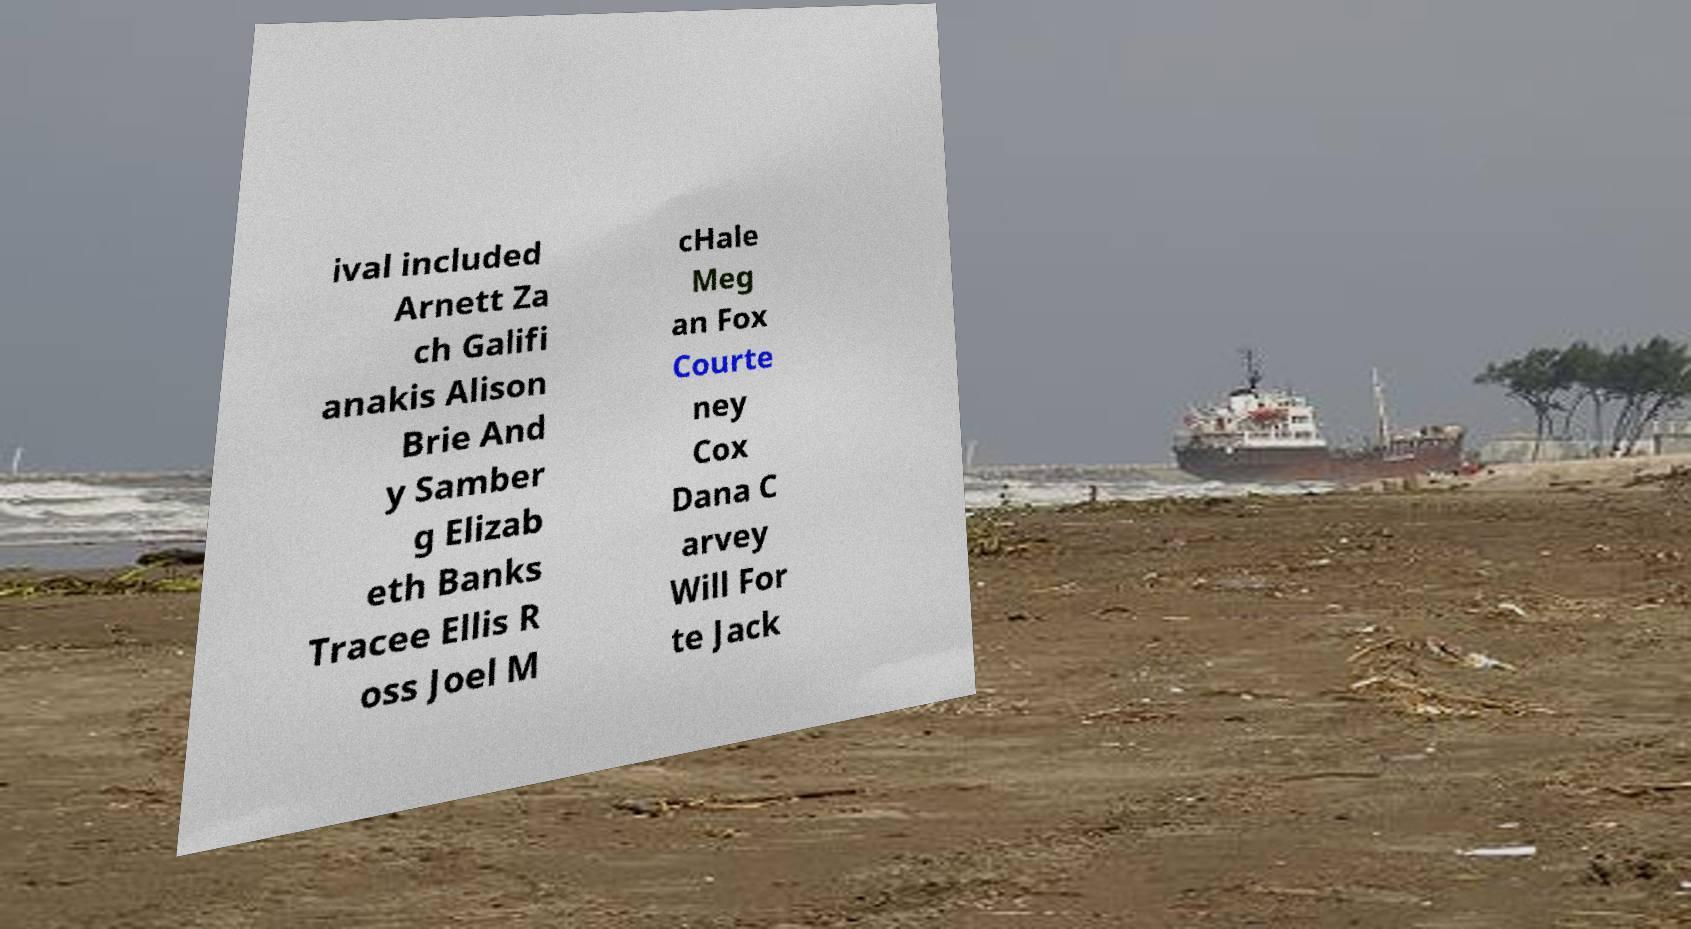There's text embedded in this image that I need extracted. Can you transcribe it verbatim? ival included Arnett Za ch Galifi anakis Alison Brie And y Samber g Elizab eth Banks Tracee Ellis R oss Joel M cHale Meg an Fox Courte ney Cox Dana C arvey Will For te Jack 